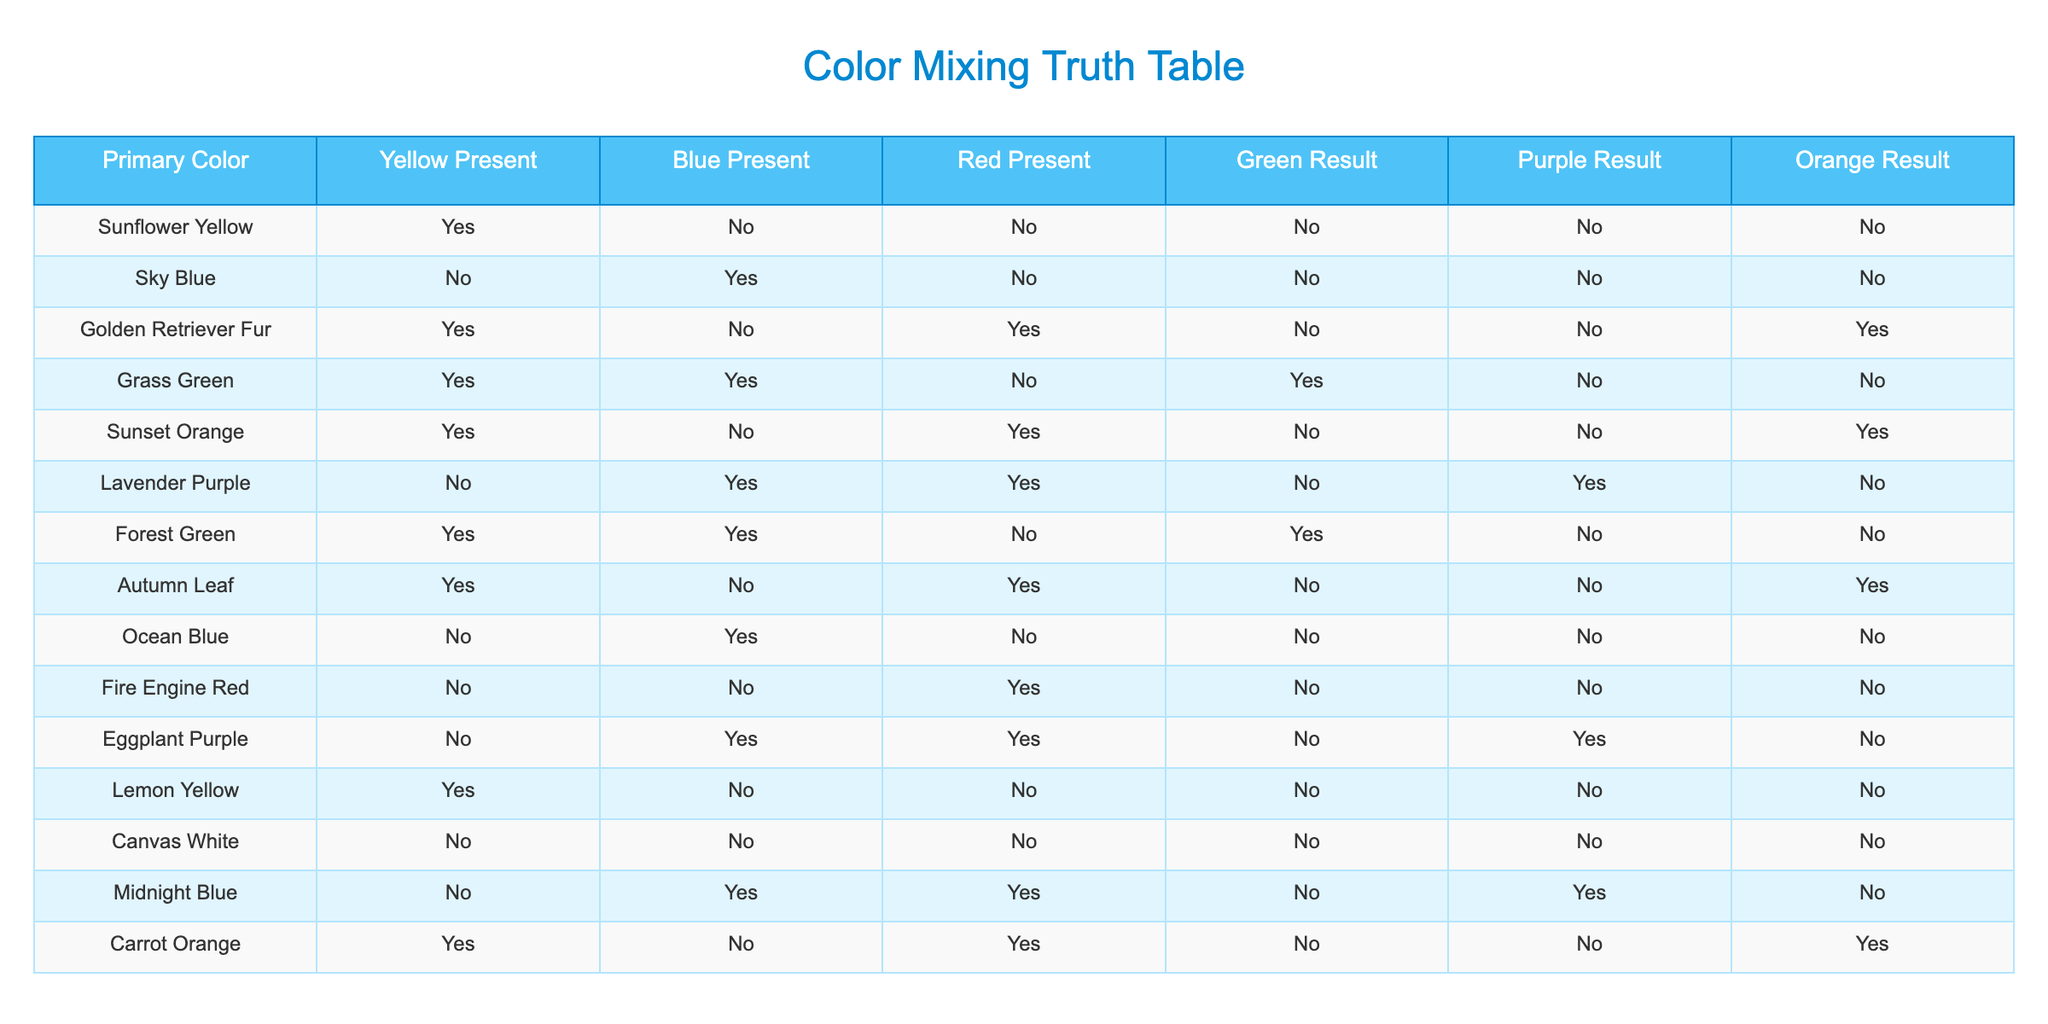What happens when both yellow and blue are present? Referring to the table, if both yellow (TRUE) and blue (TRUE) are present, we look for the row that satisfies this condition. The only instance is "Grass Green," which results in green being present (TRUE).
Answer: Green Result: Yes Is there any combination that results in purple when both yellow and red are present? By examining the table, we find that when yellow is TRUE and red is TRUE, we have the "Lavender Purple" which results in purple being present (TRUE). This confirms a successful combination for purple.
Answer: Purple Result: Yes How many colors yield orange when yellow is present? We need to count the instances where "Yellow Present" is TRUE and "Orange Result" is TRUE. Looking through the rows, we identify "Golden Retriever Fur," "Sunset Orange," and "Carrot Orange," which leads to a total of three colors.
Answer: 3 If I only have blue, what color result should I expect? Checking the rows where "Blue Present" is TRUE, we see that all those colors lead to no color results in green, purple, or orange. This indicates that having only blue does not yield any of the mentioned results.
Answer: Result: None Which combination yields both green and orange? To find combinations that result in both green and orange simultaneously, we look through the results for each color. The only row that provides TRUE for green and also TRUE for orange is "Grass Green," giving that unique case.
Answer: Grass Green What is the total number of colors that lead to a result for purple? We need to tally how many rows indicate that the "Purple Result" is TRUE. By scanning the table, we find "Lavender Purple" and "Eggplant Purple," resulting in a total of two colors that successfully yield purple.
Answer: 2 